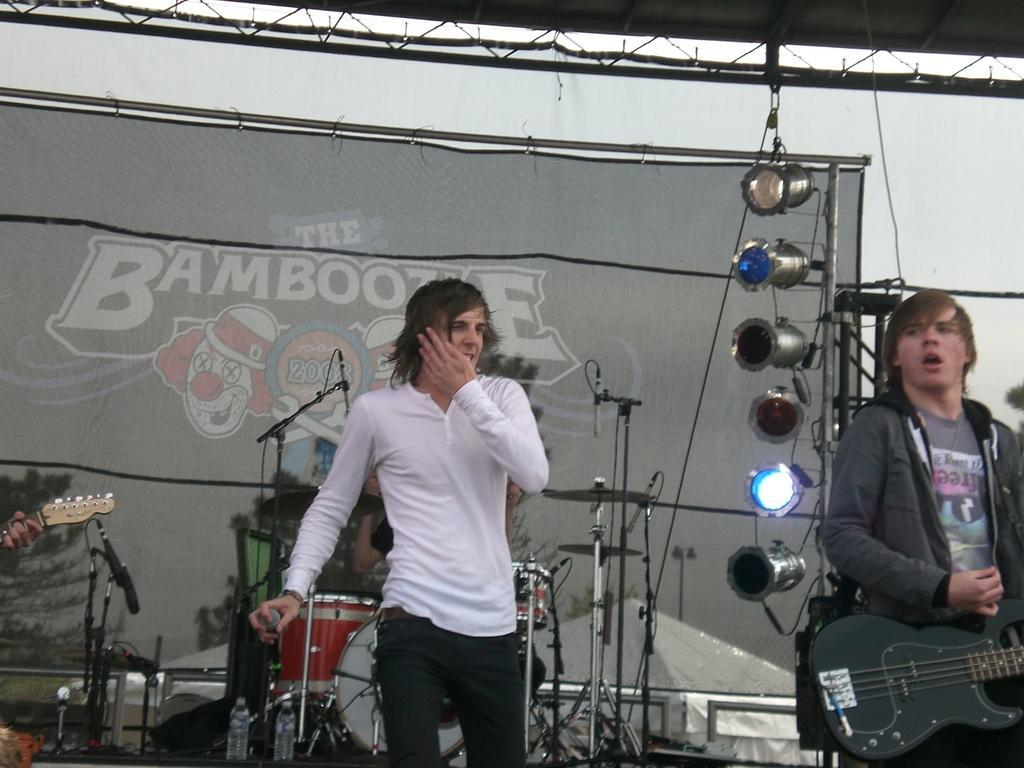Please provide a concise description of this image. The man in white t-shirt is holding a mic. The man in jacket is playing a guitar. These are focusing lights. This is a banner. These are musical instruments. 